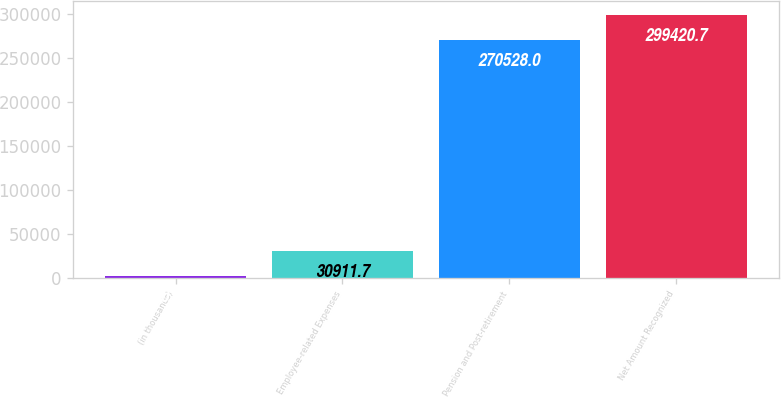Convert chart. <chart><loc_0><loc_0><loc_500><loc_500><bar_chart><fcel>(in thousands)<fcel>Employee-related Expenses<fcel>Pension and Post-retirement<fcel>Net Amount Recognized<nl><fcel>2019<fcel>30911.7<fcel>270528<fcel>299421<nl></chart> 